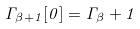Convert formula to latex. <formula><loc_0><loc_0><loc_500><loc_500>\Gamma _ { \beta + 1 } [ 0 ] = \Gamma _ { \beta } + 1</formula> 